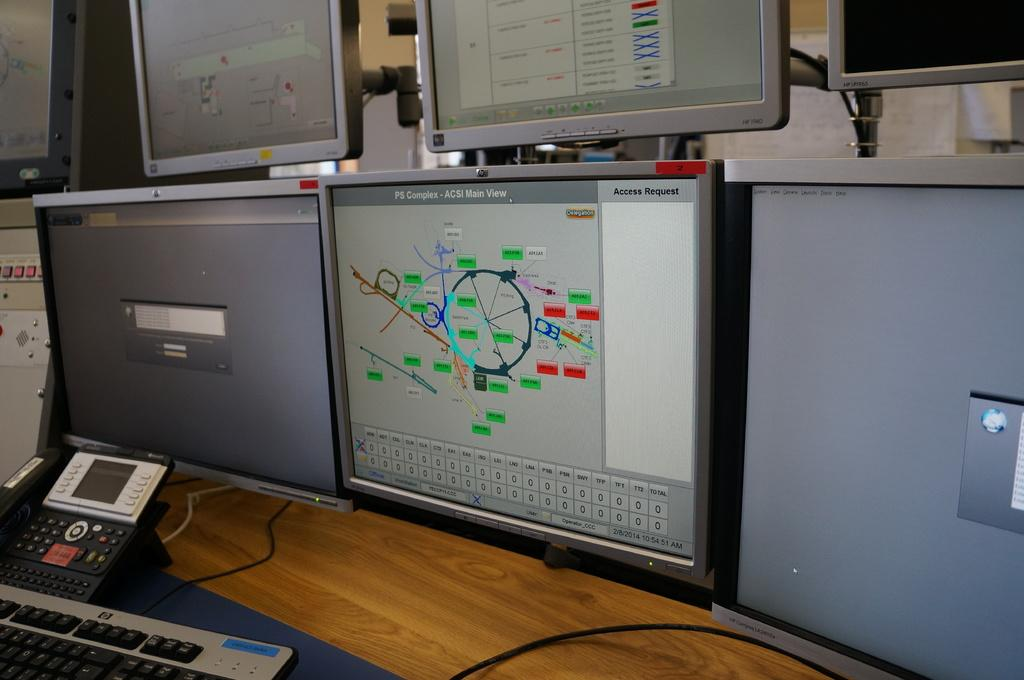<image>
Present a compact description of the photo's key features. The middle computer screen has an access request on the top right. 